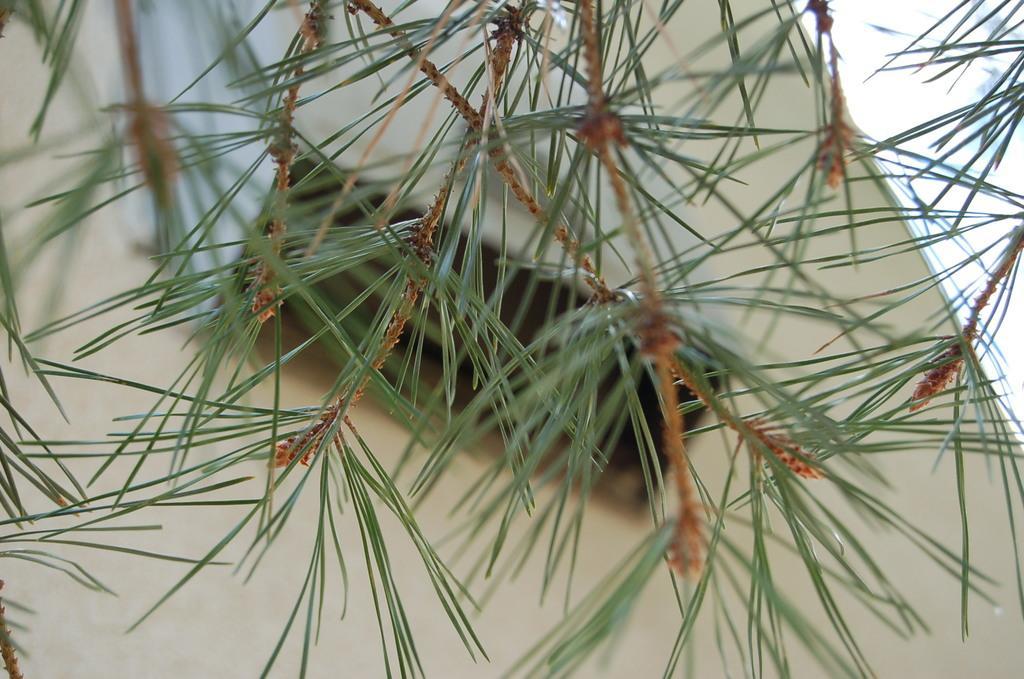Describe this image in one or two sentences. In this picture I can see leaves and stems, and in the background there is an object. 